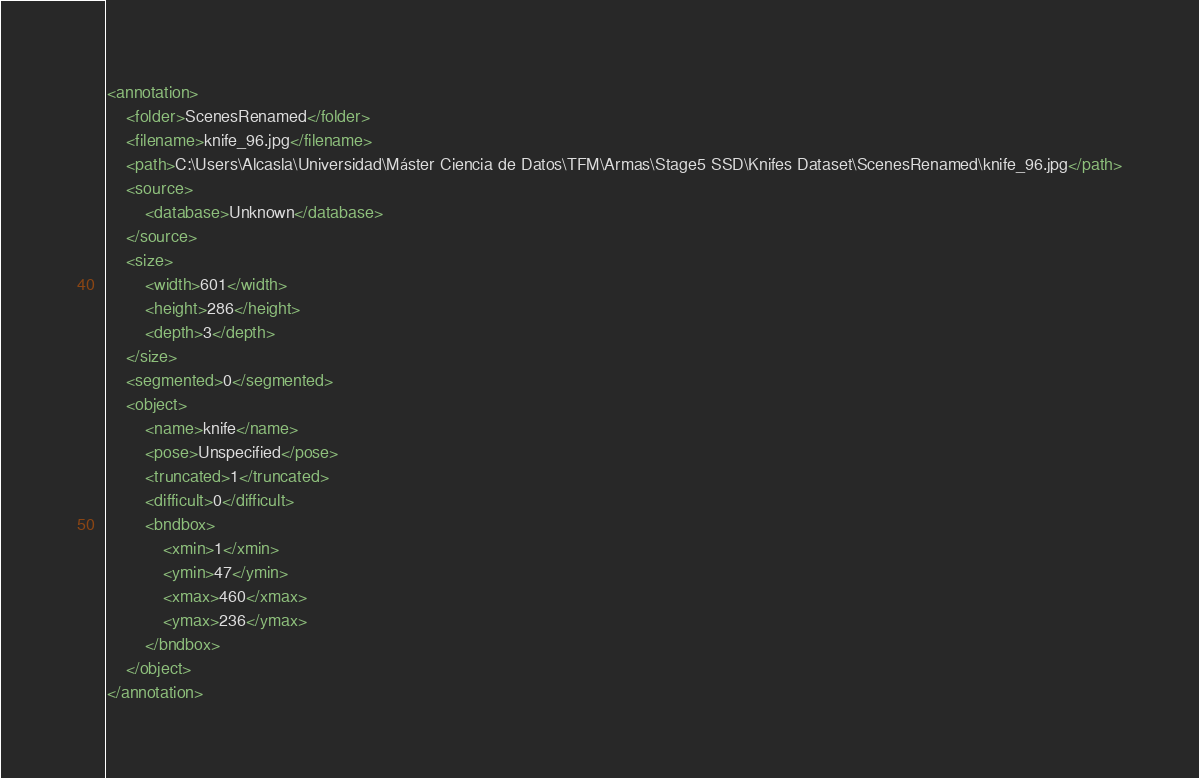Convert code to text. <code><loc_0><loc_0><loc_500><loc_500><_XML_><annotation>
	<folder>ScenesRenamed</folder>
	<filename>knife_96.jpg</filename>
	<path>C:\Users\Alcasla\Universidad\Máster Ciencia de Datos\TFM\Armas\Stage5 SSD\Knifes Dataset\ScenesRenamed\knife_96.jpg</path>
	<source>
		<database>Unknown</database>
	</source>
	<size>
		<width>601</width>
		<height>286</height>
		<depth>3</depth>
	</size>
	<segmented>0</segmented>
	<object>
		<name>knife</name>
		<pose>Unspecified</pose>
		<truncated>1</truncated>
		<difficult>0</difficult>
		<bndbox>
			<xmin>1</xmin>
			<ymin>47</ymin>
			<xmax>460</xmax>
			<ymax>236</ymax>
		</bndbox>
	</object>
</annotation>
</code> 